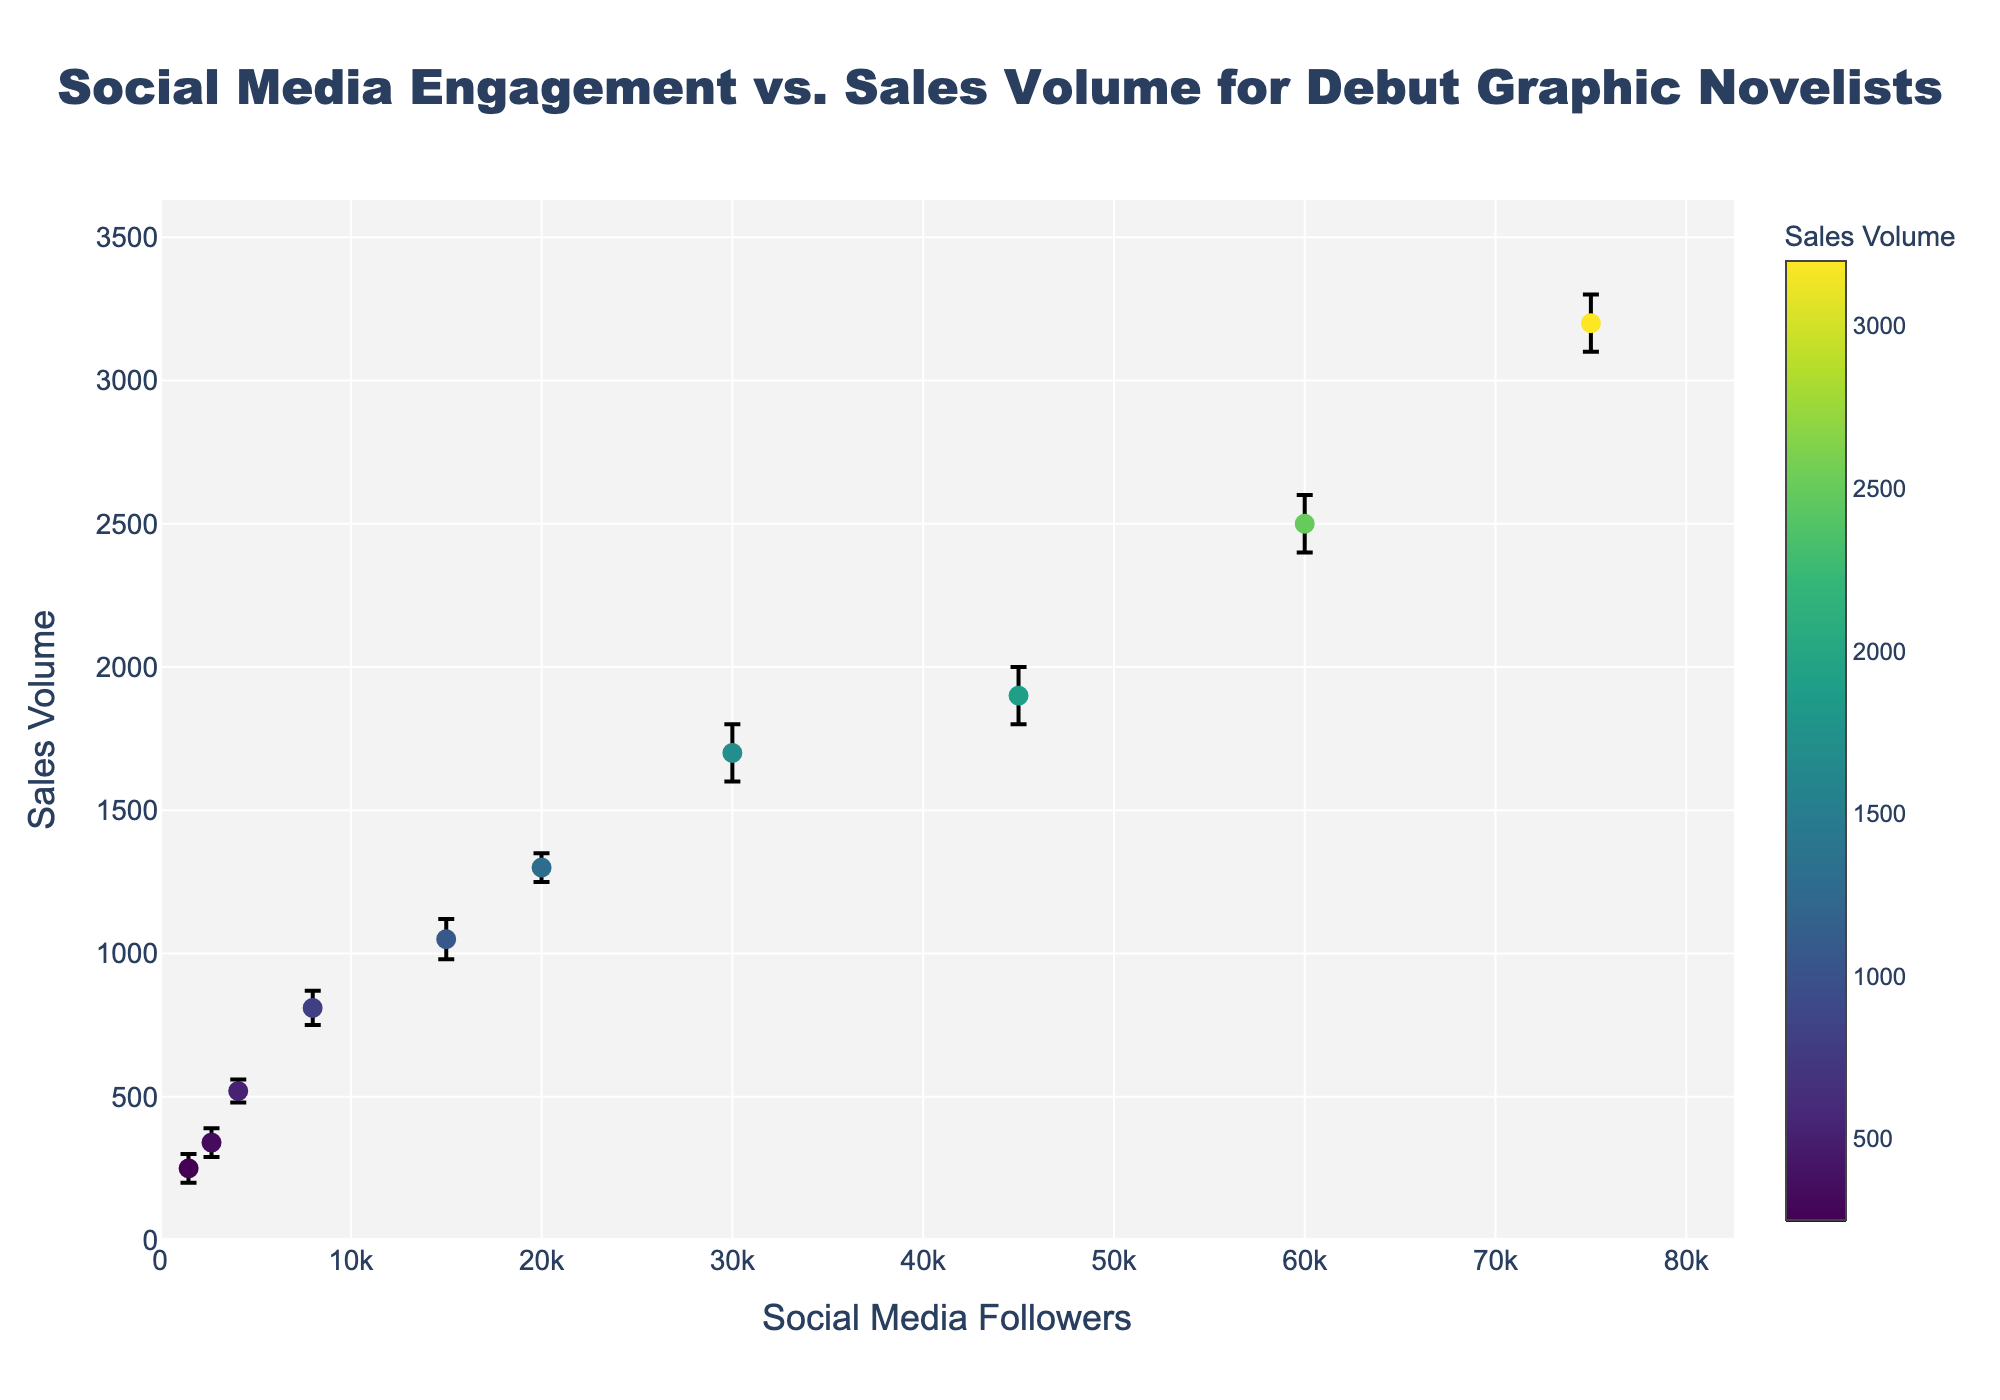What does the title of the figure indicate about the data? The title of the figure is "Social Media Engagement vs. Sales Volume for Debut Graphic Novelists", which indicates that the data visualizes the relationship between the number of social media followers and the sales volume for debut graphic novelists, along with uncertainty intervals.
Answer: Social Media Engagement vs. Sales Volume for Debut Graphic Novelists What is the range of social media followers displayed on the x-axis? The range of the x-axis extends from 0 to 82500 social media followers. This is slightly more than the highest data point, which is 75000 followers.
Answer: 0 to 82500 What is the range of sales volume displayed on the y-axis? The range of the y-axis extends from 0 to 3600 sales volume. This is slightly more than the highest data point, which is 3300 sales volume.
Answer: 0 to 3600 How many data points are represented in the scatter plot? By counting the individual markers on the scatter plot, it can be deduced that there are 10 data points represented.
Answer: 10 What is the sales volume for the graphic novelist with 15000 social media followers? Locate the data point aligned with 15000 on the x-axis; the corresponding y-value is 1050 sales volume.
Answer: 1050 Which data point has the highest sales volume? Identify the highest marker on the y-axis, which corresponds to the data point with 75000 social media followers and a sales volume of 3200.
Answer: 3200 Which data point has the widest uncertainty interval? Compare the vertical error bars of all data points; the error bar associated with 75000 followers ranges from 3100 to 3300, which is a width of 200. Hence, 75000 followers have the widest uncertainty interval.
Answer: 75000 followers How does the sales volume change as the number of social media followers increases? By observing the trend in the scatter plot, sales volume generally increases as the number of social media followers increases, showing a positive correlation.
Answer: Increases What is the average sales volume for the graphic novelists with less than 10000 followers? There are 4 data points with < 10000 followers: 250, 340, 520, 810. Calculate the average: (250 + 340 + 520 + 810) / 4 = 480.
Answer: 480 Between which two follower counts does the largest increase in sales volume occur? Examine the differences in sales volumes between consecutive follower counts: from 60000-75000 (2500-3200) the increase is 700, the largest observed.
Answer: Between 60000 and 75000 followers 